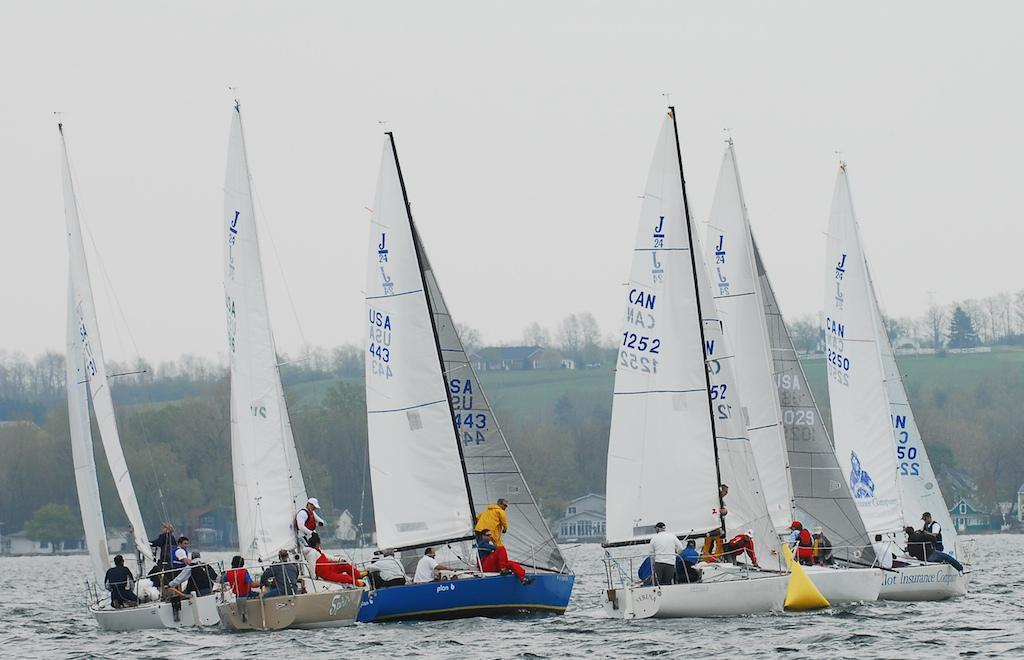<image>
Render a clear and concise summary of the photo. Several sailboats are grouped close together, including boat number 443. 